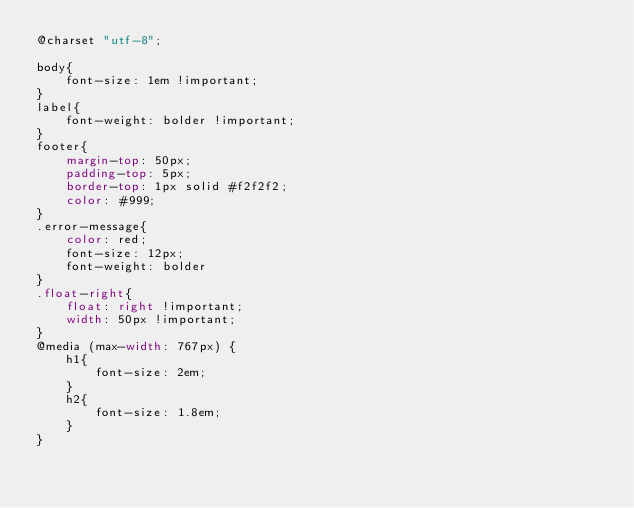<code> <loc_0><loc_0><loc_500><loc_500><_CSS_>@charset "utf-8";

body{
	font-size: 1em !important;
}
label{
	font-weight: bolder !important;
}
footer{
	margin-top: 50px;
	padding-top: 5px;
	border-top: 1px solid #f2f2f2;
	color: #999;	
}
.error-message{
	color: red;
	font-size: 12px;
	font-weight: bolder
}
.float-right{
	float: right !important;
	width: 50px !important;
}
@media (max-width: 767px) {
	h1{
		font-size: 2em;		
	}
	h2{
		font-size: 1.8em;		
	}
}</code> 